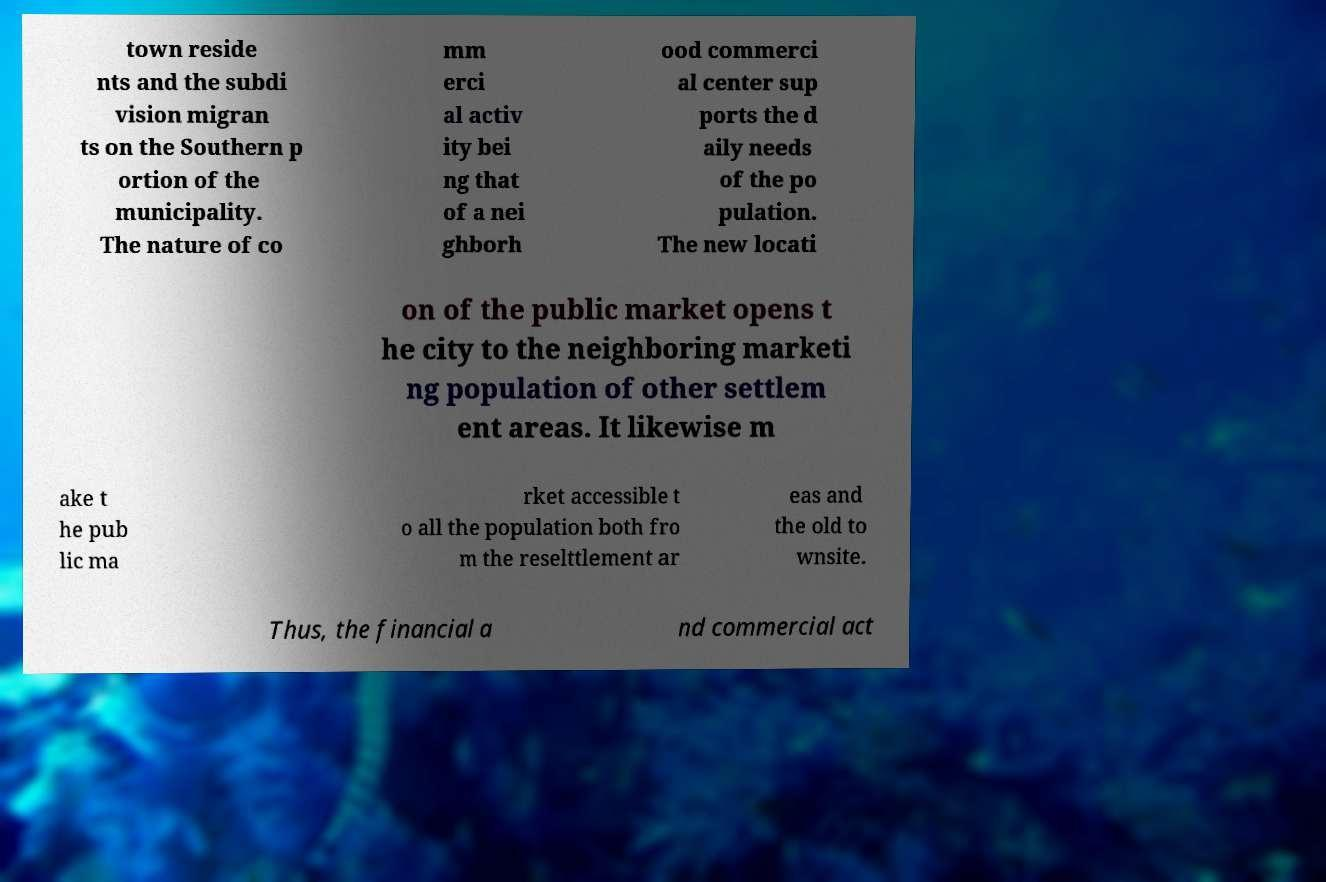Please read and relay the text visible in this image. What does it say? town reside nts and the subdi vision migran ts on the Southern p ortion of the municipality. The nature of co mm erci al activ ity bei ng that of a nei ghborh ood commerci al center sup ports the d aily needs of the po pulation. The new locati on of the public market opens t he city to the neighboring marketi ng population of other settlem ent areas. It likewise m ake t he pub lic ma rket accessible t o all the population both fro m the reselttlement ar eas and the old to wnsite. Thus, the financial a nd commercial act 